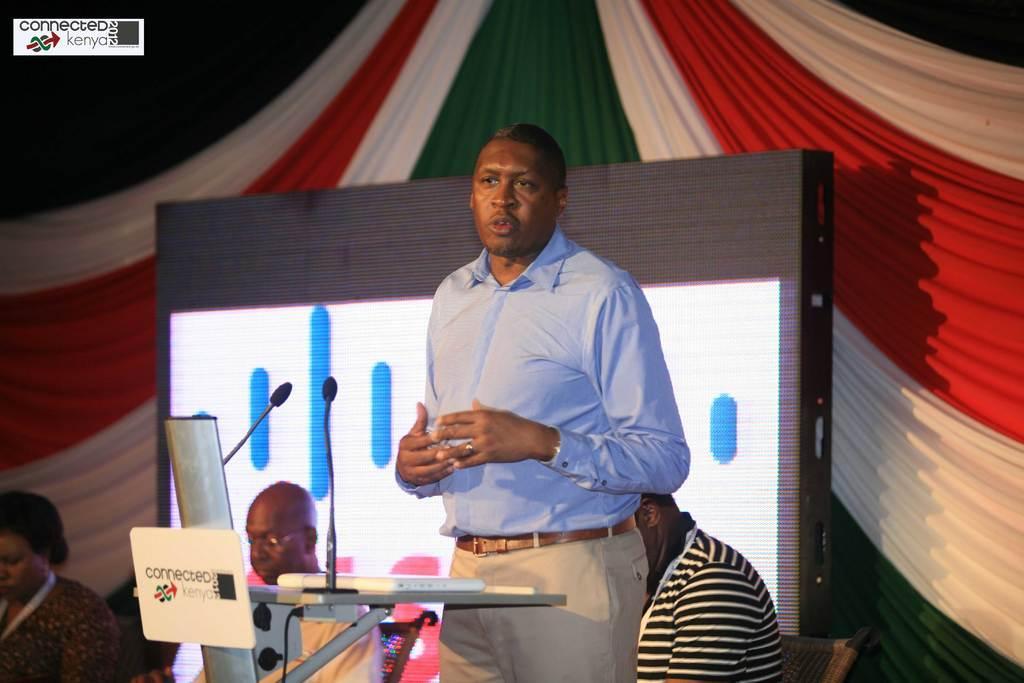Can you describe this image briefly? In front of the image there is a person standing, in front of the person on the podium there is a laptop, mic, name board and some other objects, behind them there are a few other people seated in chairs, behind them there is a screen and a curtain, at the top left of the image there is a logo with text. 